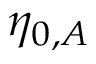<formula> <loc_0><loc_0><loc_500><loc_500>\eta _ { 0 , A }</formula> 